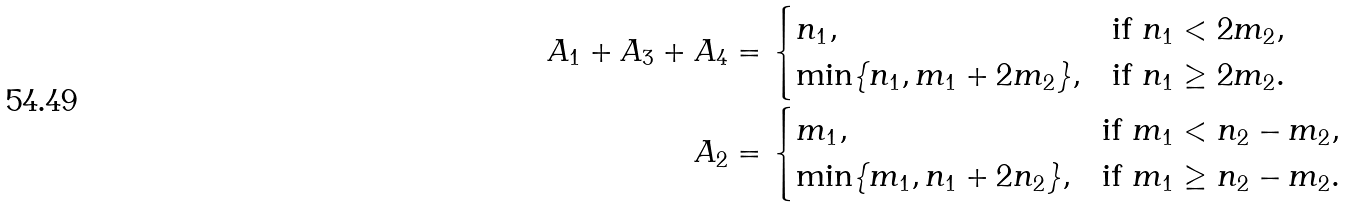<formula> <loc_0><loc_0><loc_500><loc_500>A _ { 1 } + A _ { 3 } + A _ { 4 } & = \begin{cases} n _ { 1 } , & \text {if } n _ { 1 } < 2 m _ { 2 } , \\ \min \{ n _ { 1 } , m _ { 1 } + 2 m _ { 2 } \} , & \text {if } n _ { 1 } \geq 2 m _ { 2 } . \end{cases} \\ A _ { 2 } & = \begin{cases} m _ { 1 } , & \text {if } m _ { 1 } < n _ { 2 } - m _ { 2 } , \\ \min \{ m _ { 1 } , n _ { 1 } + 2 n _ { 2 } \} , & \text {if } m _ { 1 } \geq n _ { 2 } - m _ { 2 } . \end{cases}</formula> 